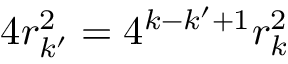<formula> <loc_0><loc_0><loc_500><loc_500>4 r _ { k ^ { \prime } } ^ { 2 } = 4 ^ { k - k ^ { \prime } + 1 } r _ { k } ^ { 2 }</formula> 